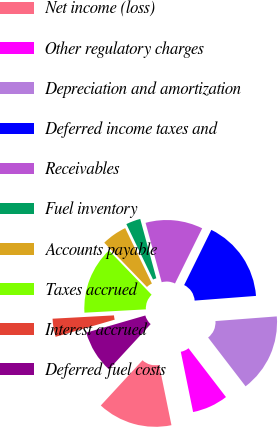<chart> <loc_0><loc_0><loc_500><loc_500><pie_chart><fcel>Net income (loss)<fcel>Other regulatory charges<fcel>Depreciation and amortization<fcel>Deferred income taxes and<fcel>Receivables<fcel>Fuel inventory<fcel>Accounts payable<fcel>Taxes accrued<fcel>Interest accrued<fcel>Deferred fuel costs<nl><fcel>15.07%<fcel>7.21%<fcel>15.79%<fcel>16.5%<fcel>11.5%<fcel>2.93%<fcel>5.07%<fcel>13.64%<fcel>3.64%<fcel>8.64%<nl></chart> 